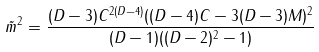<formula> <loc_0><loc_0><loc_500><loc_500>\tilde { m } ^ { 2 } = \frac { ( D - 3 ) C ^ { 2 ( D - 4 ) } ( ( D - 4 ) C - 3 ( D - 3 ) M ) ^ { 2 } } { ( D - 1 ) ( ( D - 2 ) ^ { 2 } - 1 ) }</formula> 